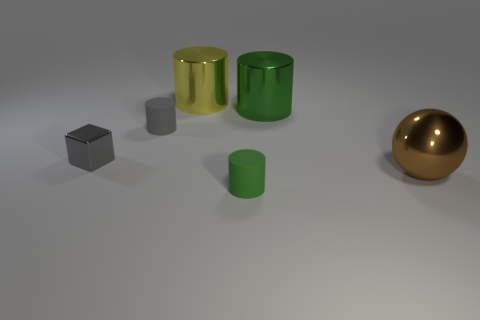Do the big thing that is in front of the cube and the large cylinder that is behind the green shiny thing have the same material?
Offer a terse response. Yes. What is the size of the green object that is in front of the small metallic block?
Give a very brief answer. Small. The yellow shiny cylinder is what size?
Offer a very short reply. Large. There is a cylinder that is in front of the big thing right of the green thing that is to the right of the tiny green cylinder; what size is it?
Ensure brevity in your answer.  Small. Is there a small cylinder that has the same material as the tiny cube?
Keep it short and to the point. No. There is a large yellow thing; what shape is it?
Your answer should be very brief. Cylinder. There is a block that is the same material as the ball; what is its color?
Offer a very short reply. Gray. What number of purple things are either shiny things or matte cylinders?
Ensure brevity in your answer.  0. Is the number of big gray things greater than the number of metallic cylinders?
Provide a short and direct response. No. How many objects are either small green rubber objects that are in front of the brown object or tiny green rubber cylinders that are in front of the big brown sphere?
Your answer should be compact. 1. 